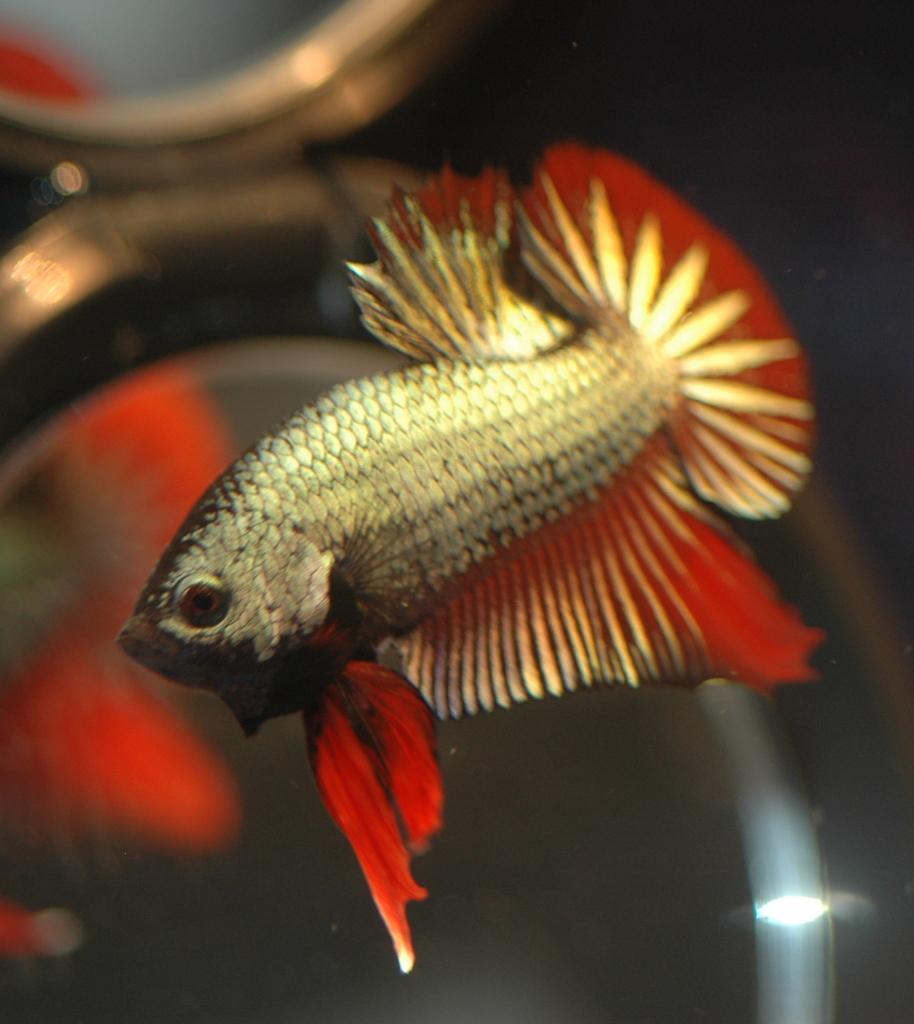Can you describe this image briefly? In the center of the image we can see a fish in the water. 